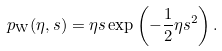Convert formula to latex. <formula><loc_0><loc_0><loc_500><loc_500>p _ { \text {W} } ( \eta , s ) = \eta s \exp \left ( - \frac { 1 } { 2 } \eta s ^ { 2 } \right ) .</formula> 